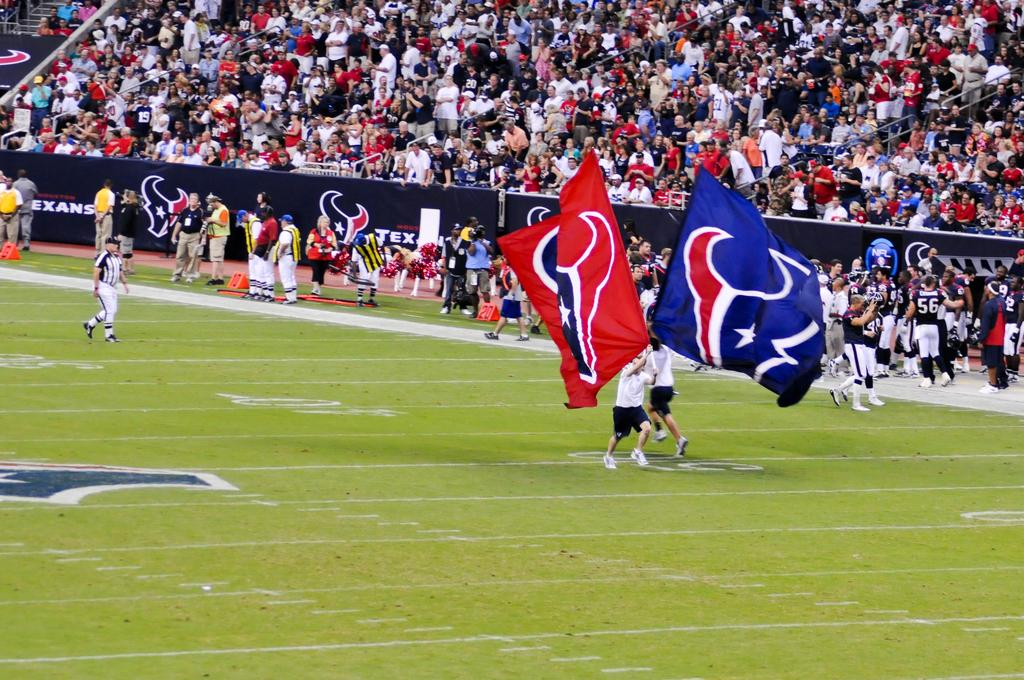How many people are in the image? There are people in the image, specifically two people who are running. What are the two people doing while running? The two people are holding flags while running. What can be seen in the background of the image? There are hoardings and rods visible in the background, as well as an audience. Why are the people holding umbrellas while running in the image? There are no umbrellas present in the image; the two people are holding flags while running. 